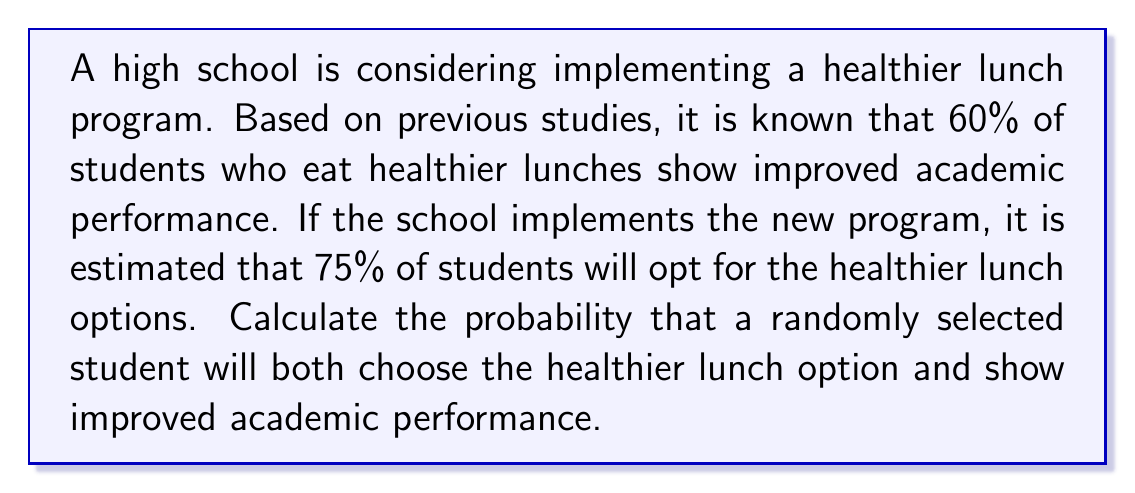Can you solve this math problem? To solve this problem, we need to use the concept of conditional probability. Let's define our events:

A: Student chooses healthier lunch option
B: Student shows improved academic performance

We are given:
P(B|A) = 0.60 (probability of improved performance given healthier lunch)
P(A) = 0.75 (probability of choosing healthier lunch)

We want to find P(A ∩ B), which is the probability of both events occurring.

We can use the multiplication rule of probability:

$$ P(A ∩ B) = P(A) \cdot P(B|A) $$

Substituting our known values:

$$ P(A ∩ B) = 0.75 \cdot 0.60 $$

$$ P(A ∩ B) = 0.45 $$

Therefore, the probability that a randomly selected student will both choose the healthier lunch option and show improved academic performance is 0.45 or 45%.
Answer: 0.45 or 45% 